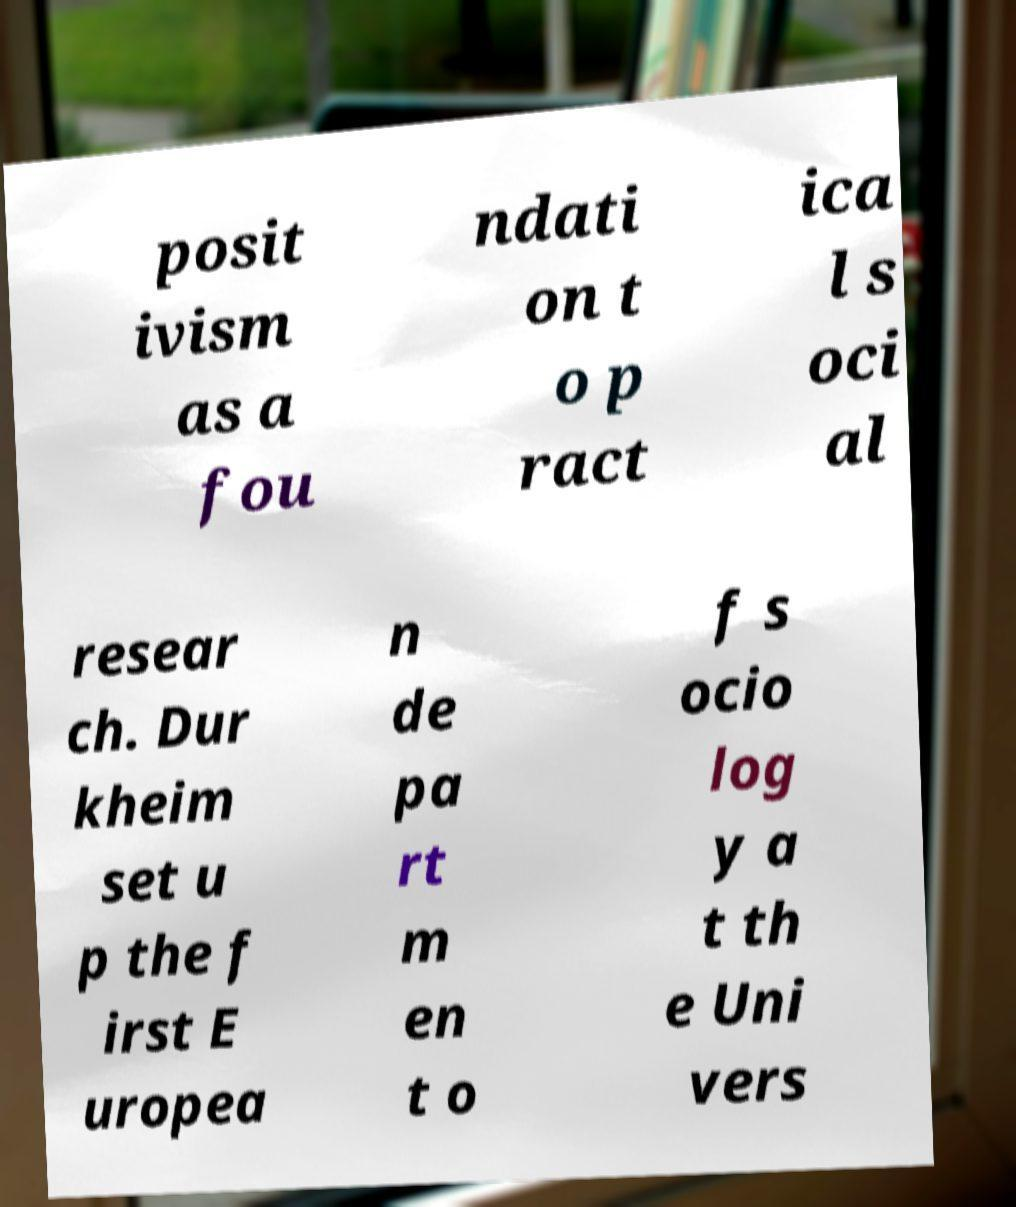I need the written content from this picture converted into text. Can you do that? posit ivism as a fou ndati on t o p ract ica l s oci al resear ch. Dur kheim set u p the f irst E uropea n de pa rt m en t o f s ocio log y a t th e Uni vers 